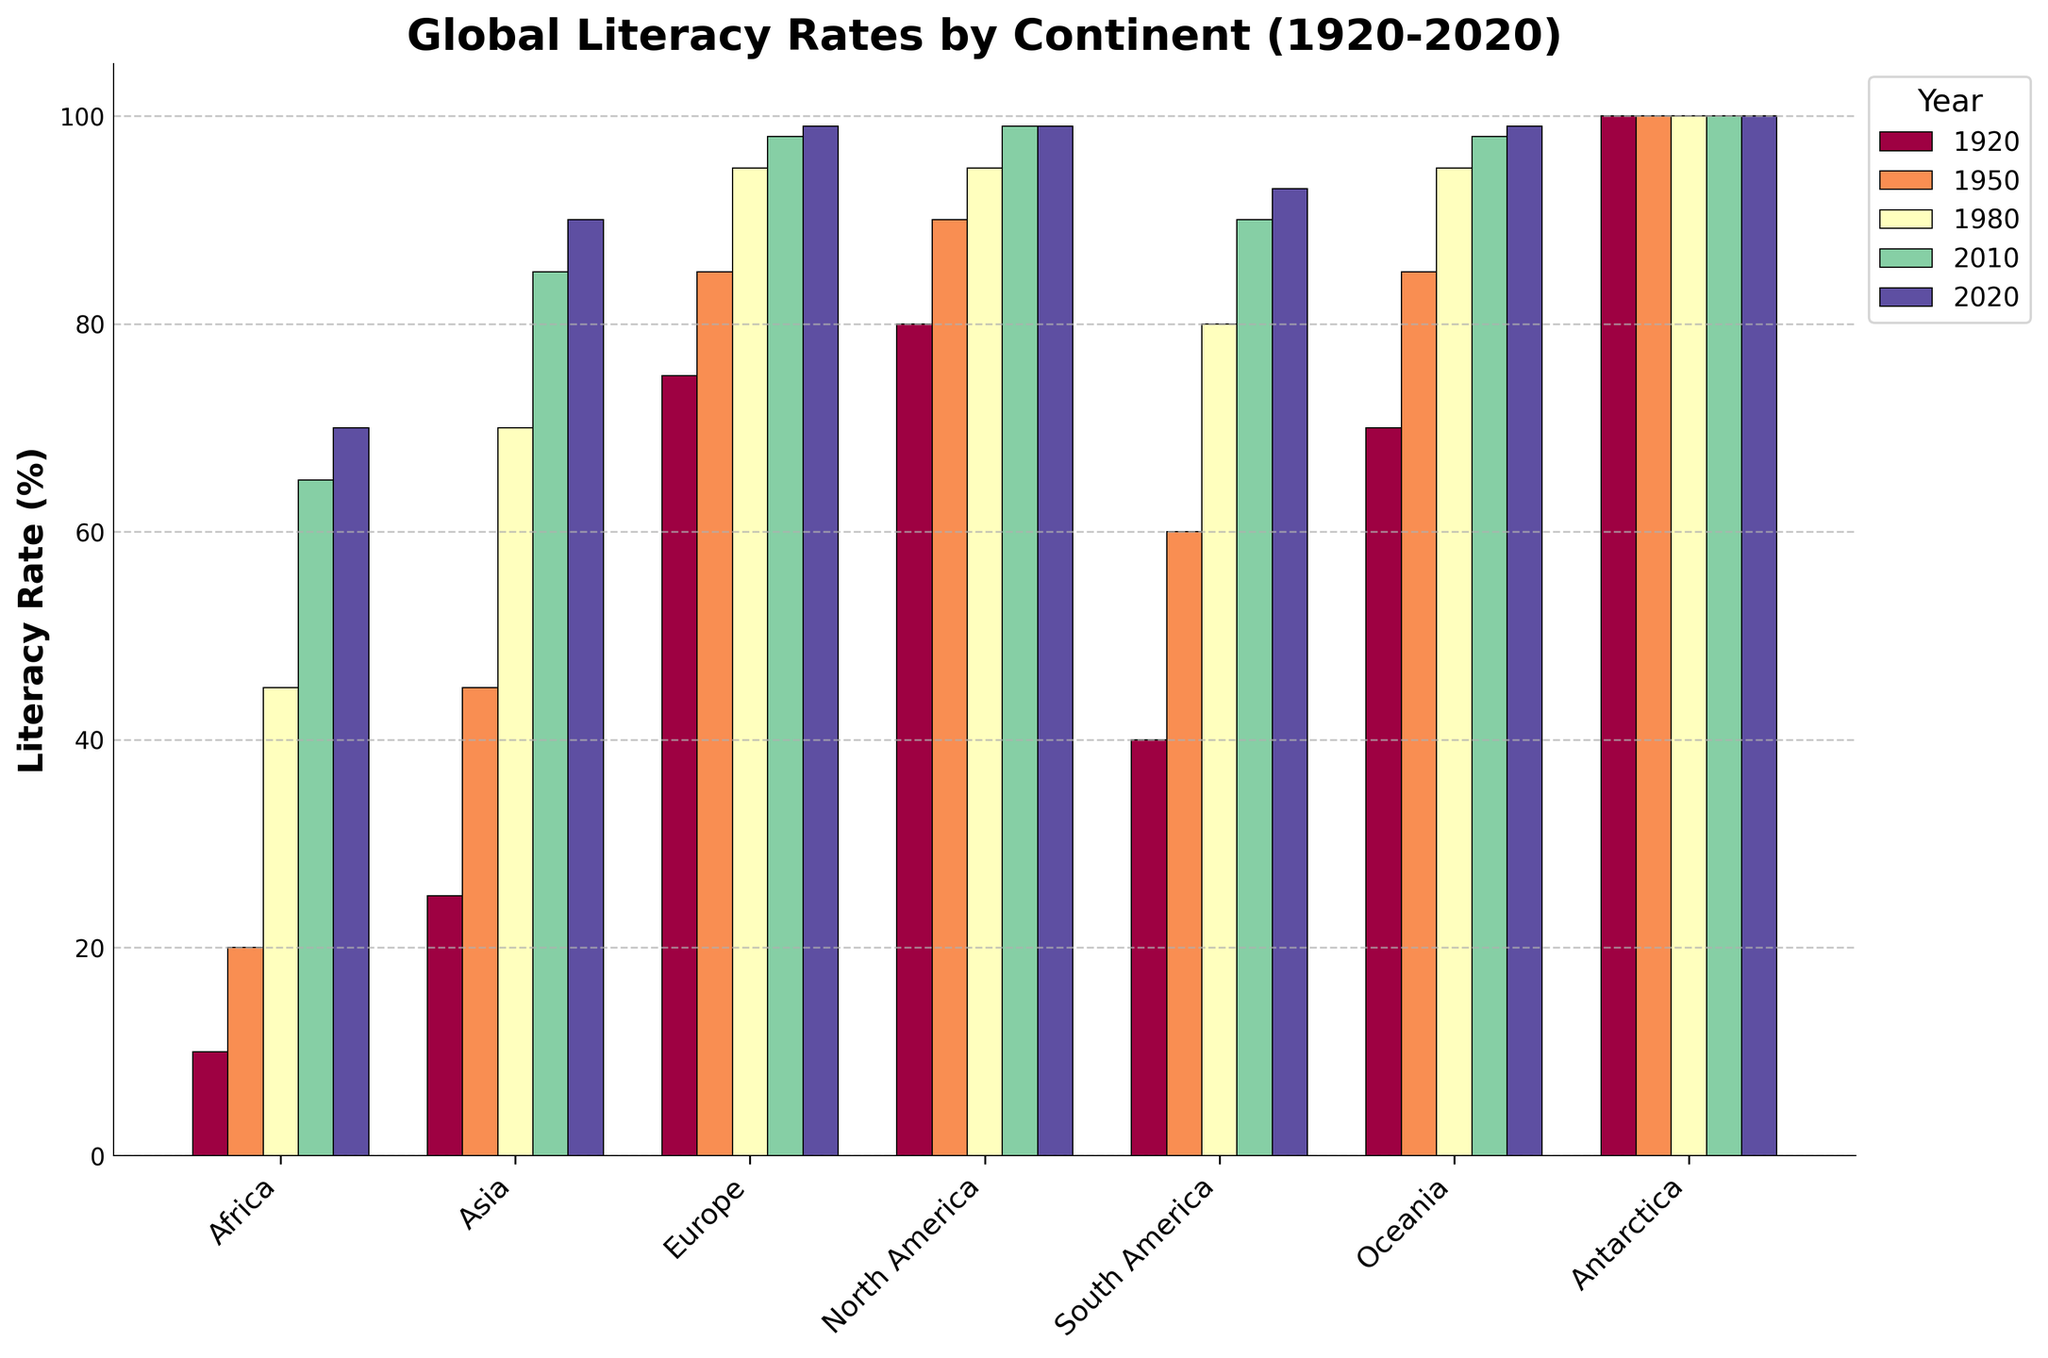What was the literacy rate in Africa in 1920 and 2020, and by how much did it increase? The literacy rate in Africa in 1920 was 10%, and in 2020 it was 70%. The increase can be calculated as 70% - 10% = 60%.
Answer: 60% Which continent had the highest literacy rate in 2010? In the 2010 bar, both Europe and Oceania are at 98%, while North America is at 99%. North America had the highest literacy rate in 2010.
Answer: North America How did the literacy rate in South America change from 1950 to 1980? The literacy rate in South America in 1950 was 60%, and in 1980 it was 80%. The increase is 80% - 60% = 20%.
Answer: 20% How many continents had a literacy rate of 99% or higher in 2020? In the 2020 bar, North America, Europe, and Oceania all had literacy rates of 99%. Three continents had a literacy rate of 99% or higher.
Answer: 3 What is the average literacy rate of Asia across all the years shown in the chart? Sum the literacy rates of Asia (25+45+70+85+90) = 315, then divide by the number of years (5): 315 / 5 = 63.
Answer: 63 Which continent had the smallest increase in literacy rate between 1920 and 2020? Antarctica had a consistent literacy rate of 100% across all years and thus had the smallest increase (0%).
Answer: Antarctica Between 1980 and 2020, which continent witnessed the biggest increase in literacy rate? From 1980 to 2020, Africa increased from 45% to 70%, which is an increase of 25%. For other continents: 
- Asia: 90 - 70 = 20
- Europe: 99 - 95 = 4
- North America: 99 - 95 = 4
- South America: 93 - 80 = 13
- Oceania: 99 - 95 = 4
Africa witnessed the biggest increase.
Answer: Africa Looking at the colors used for different years, which year is represented by the darkest color bar in the chart? The default color map used (Spectral) typically assigns darker colors for earlier years. Hence, the darkest bar is associated with 1920.
Answer: 1920 